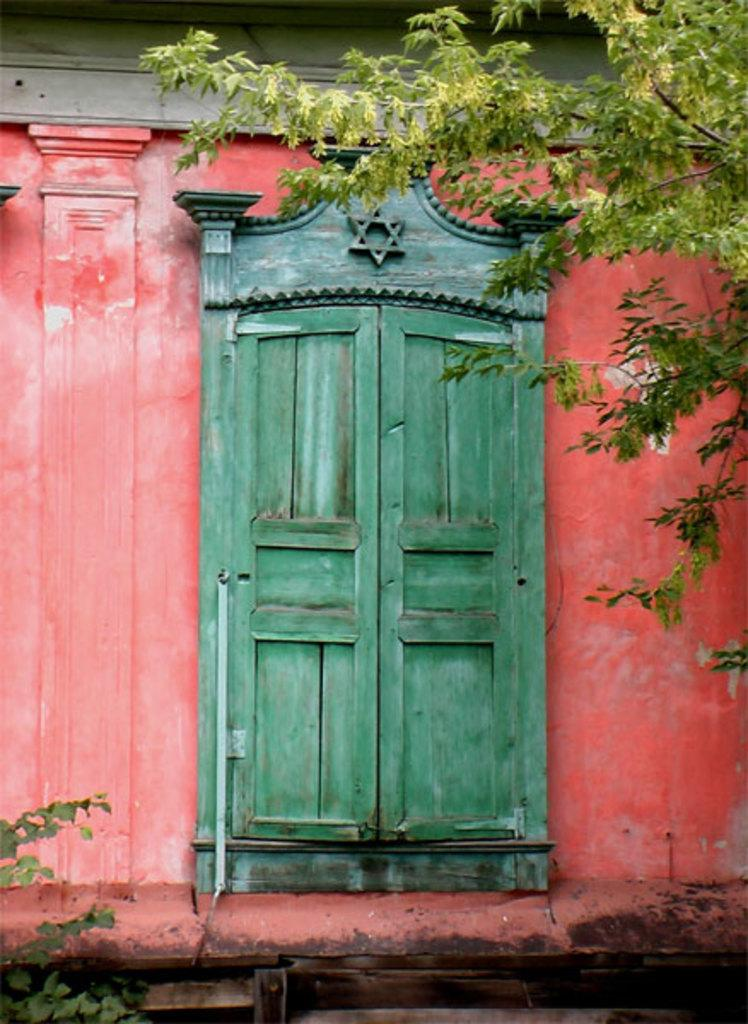What type of structure can be seen in the image? There is a wall with a door in the image. What natural element is present in the image? There is a tree in the image. Are there any other plants visible in the image? Yes, there is a plant in the image. What impulse does the tree have in the image? There is no indication of an impulse in the image; the tree is a stationary object. 